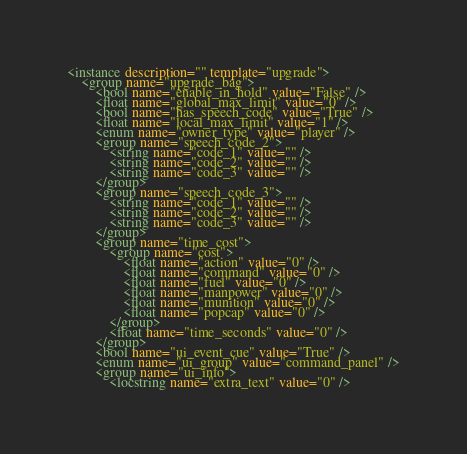<code> <loc_0><loc_0><loc_500><loc_500><_XML_><instance description="" template="upgrade">
	<group name="upgrade_bag">
		<bool name="enable_in_hold" value="False" />
		<float name="global_max_limit" value="0" />
		<bool name="has_speech_code" value="True" />
		<float name="local_max_limit" value="1" />
		<enum name="owner_type" value="player" />
		<group name="speech_code_2">
			<string name="code_1" value="" />
			<string name="code_2" value="" />
			<string name="code_3" value="" />
		</group>
		<group name="speech_code_3">
			<string name="code_1" value="" />
			<string name="code_2" value="" />
			<string name="code_3" value="" />
		</group>
		<group name="time_cost">
			<group name="cost">
				<float name="action" value="0" />
				<float name="command" value="0" />
				<float name="fuel" value="0" />
				<float name="manpower" value="0" />
				<float name="munition" value="0" />
				<float name="popcap" value="0" />
			</group>
			<float name="time_seconds" value="0" />
		</group>
		<bool name="ui_event_cue" value="True" />
		<enum name="ui_group" value="command_panel" />
		<group name="ui_info">
			<locstring name="extra_text" value="0" /></code> 